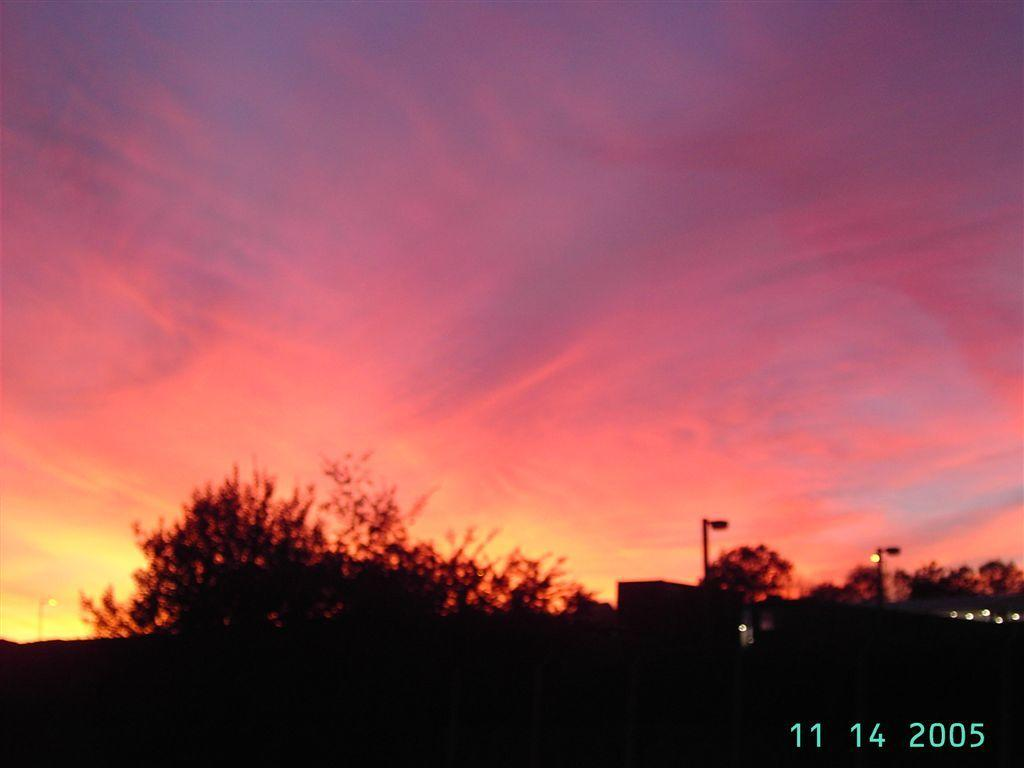What type of vegetation can be seen in the image? There are trees in the image. Where are the street lights located in the image? There are two street lights on the right side of the image. What is visible at the top of the image? The sky is visible at the top of the image. What numbers can be found in the right side bottom corner of the image? The numbers 11, 14, and 2005 are in the right side bottom corner of the image. Can you see a cabbage being lifted by a self in the image? There is no cabbage or self present in the image, and therefore no such activity can be observed. 